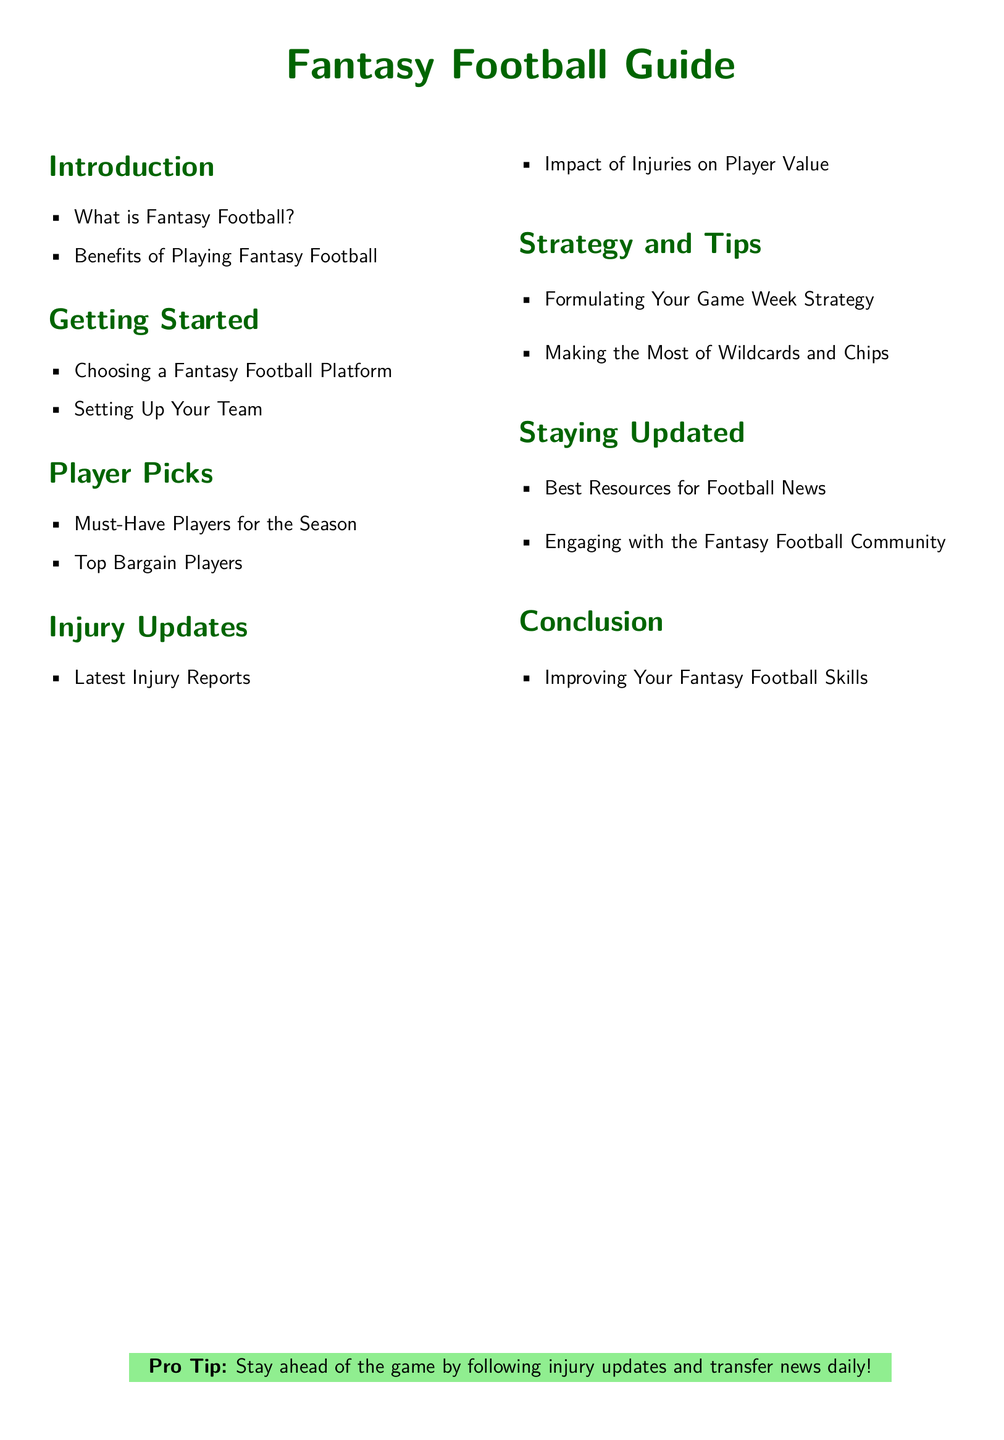What is Fantasy Football? The document provides an overview of what Fantasy Football is in the Introduction section.
Answer: Fantasy Football What are Must-Have Players for the Season? This information can be found under the Player Picks section, specifically in the list of essential players.
Answer: Must-Have Players What is the title of the document? The title of the document is presented prominently at the top.
Answer: Fantasy Football Guide What is the Pro Tip provided in the conclusion? The Pro Tip is mentioned in the conclusion section highlighted in a light green box.
Answer: Stay ahead of the game by following injury updates and transfer news daily! How many sections are there in the document? The document includes multiple sections listed in the multi-column format.
Answer: Seven sections 